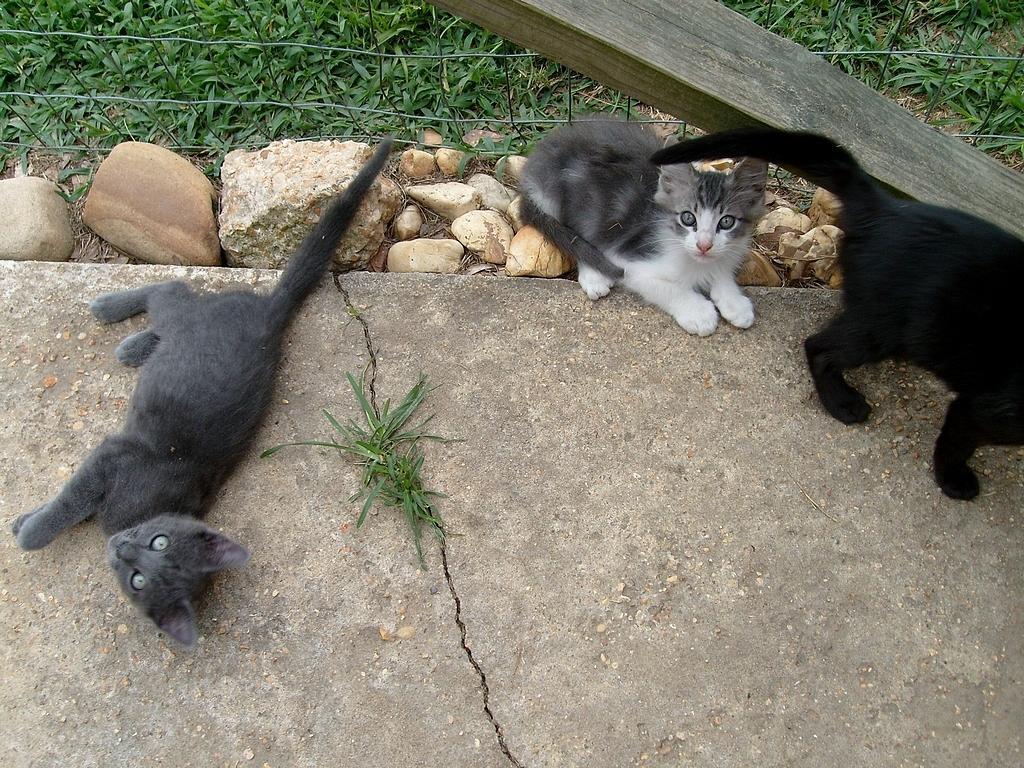Could you give a brief overview of what you see in this image? There is a black color cat laying on the floor near grass and stones, which are arranged on the ground, near fencing. On the right side, there is a black color cat, which is standing near a wooden piece and near a cat, which is sitting on the stones. In the background, there's grass on the ground. 